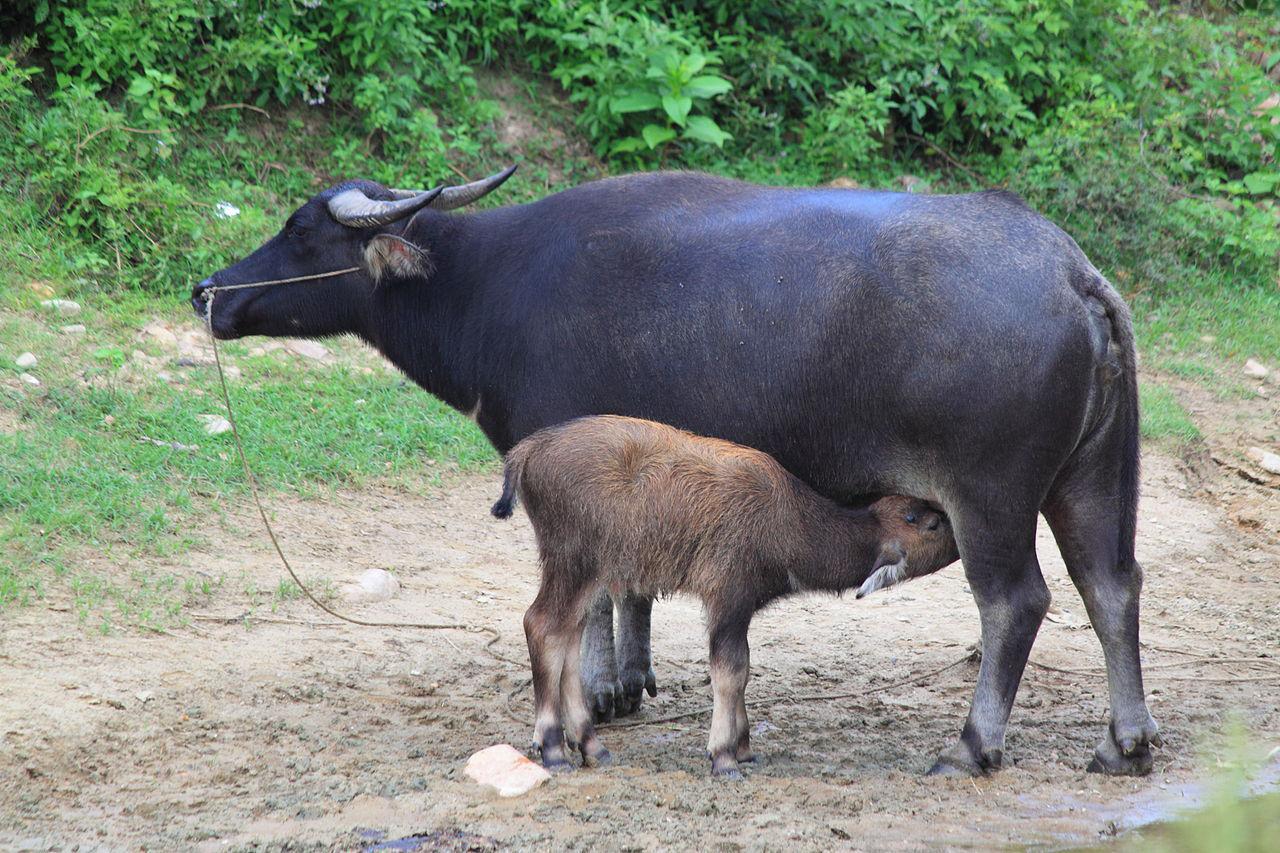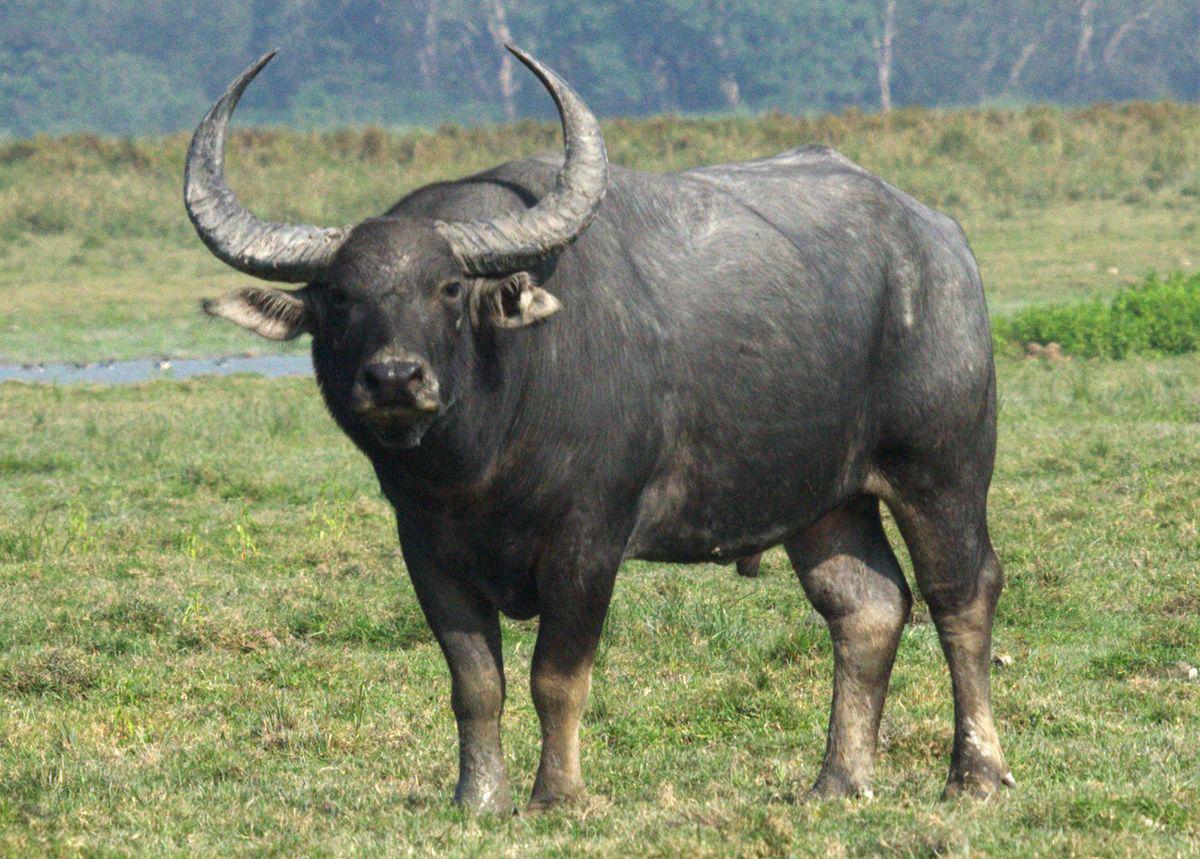The first image is the image on the left, the second image is the image on the right. Evaluate the accuracy of this statement regarding the images: "The left image contains two water buffalo's.". Is it true? Answer yes or no. Yes. The first image is the image on the left, the second image is the image on the right. For the images shown, is this caption "Left image contains twice as many hooved animals as the right image." true? Answer yes or no. Yes. 